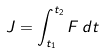<formula> <loc_0><loc_0><loc_500><loc_500>J = \int _ { t _ { 1 } } ^ { t _ { 2 } } F \, d t</formula> 